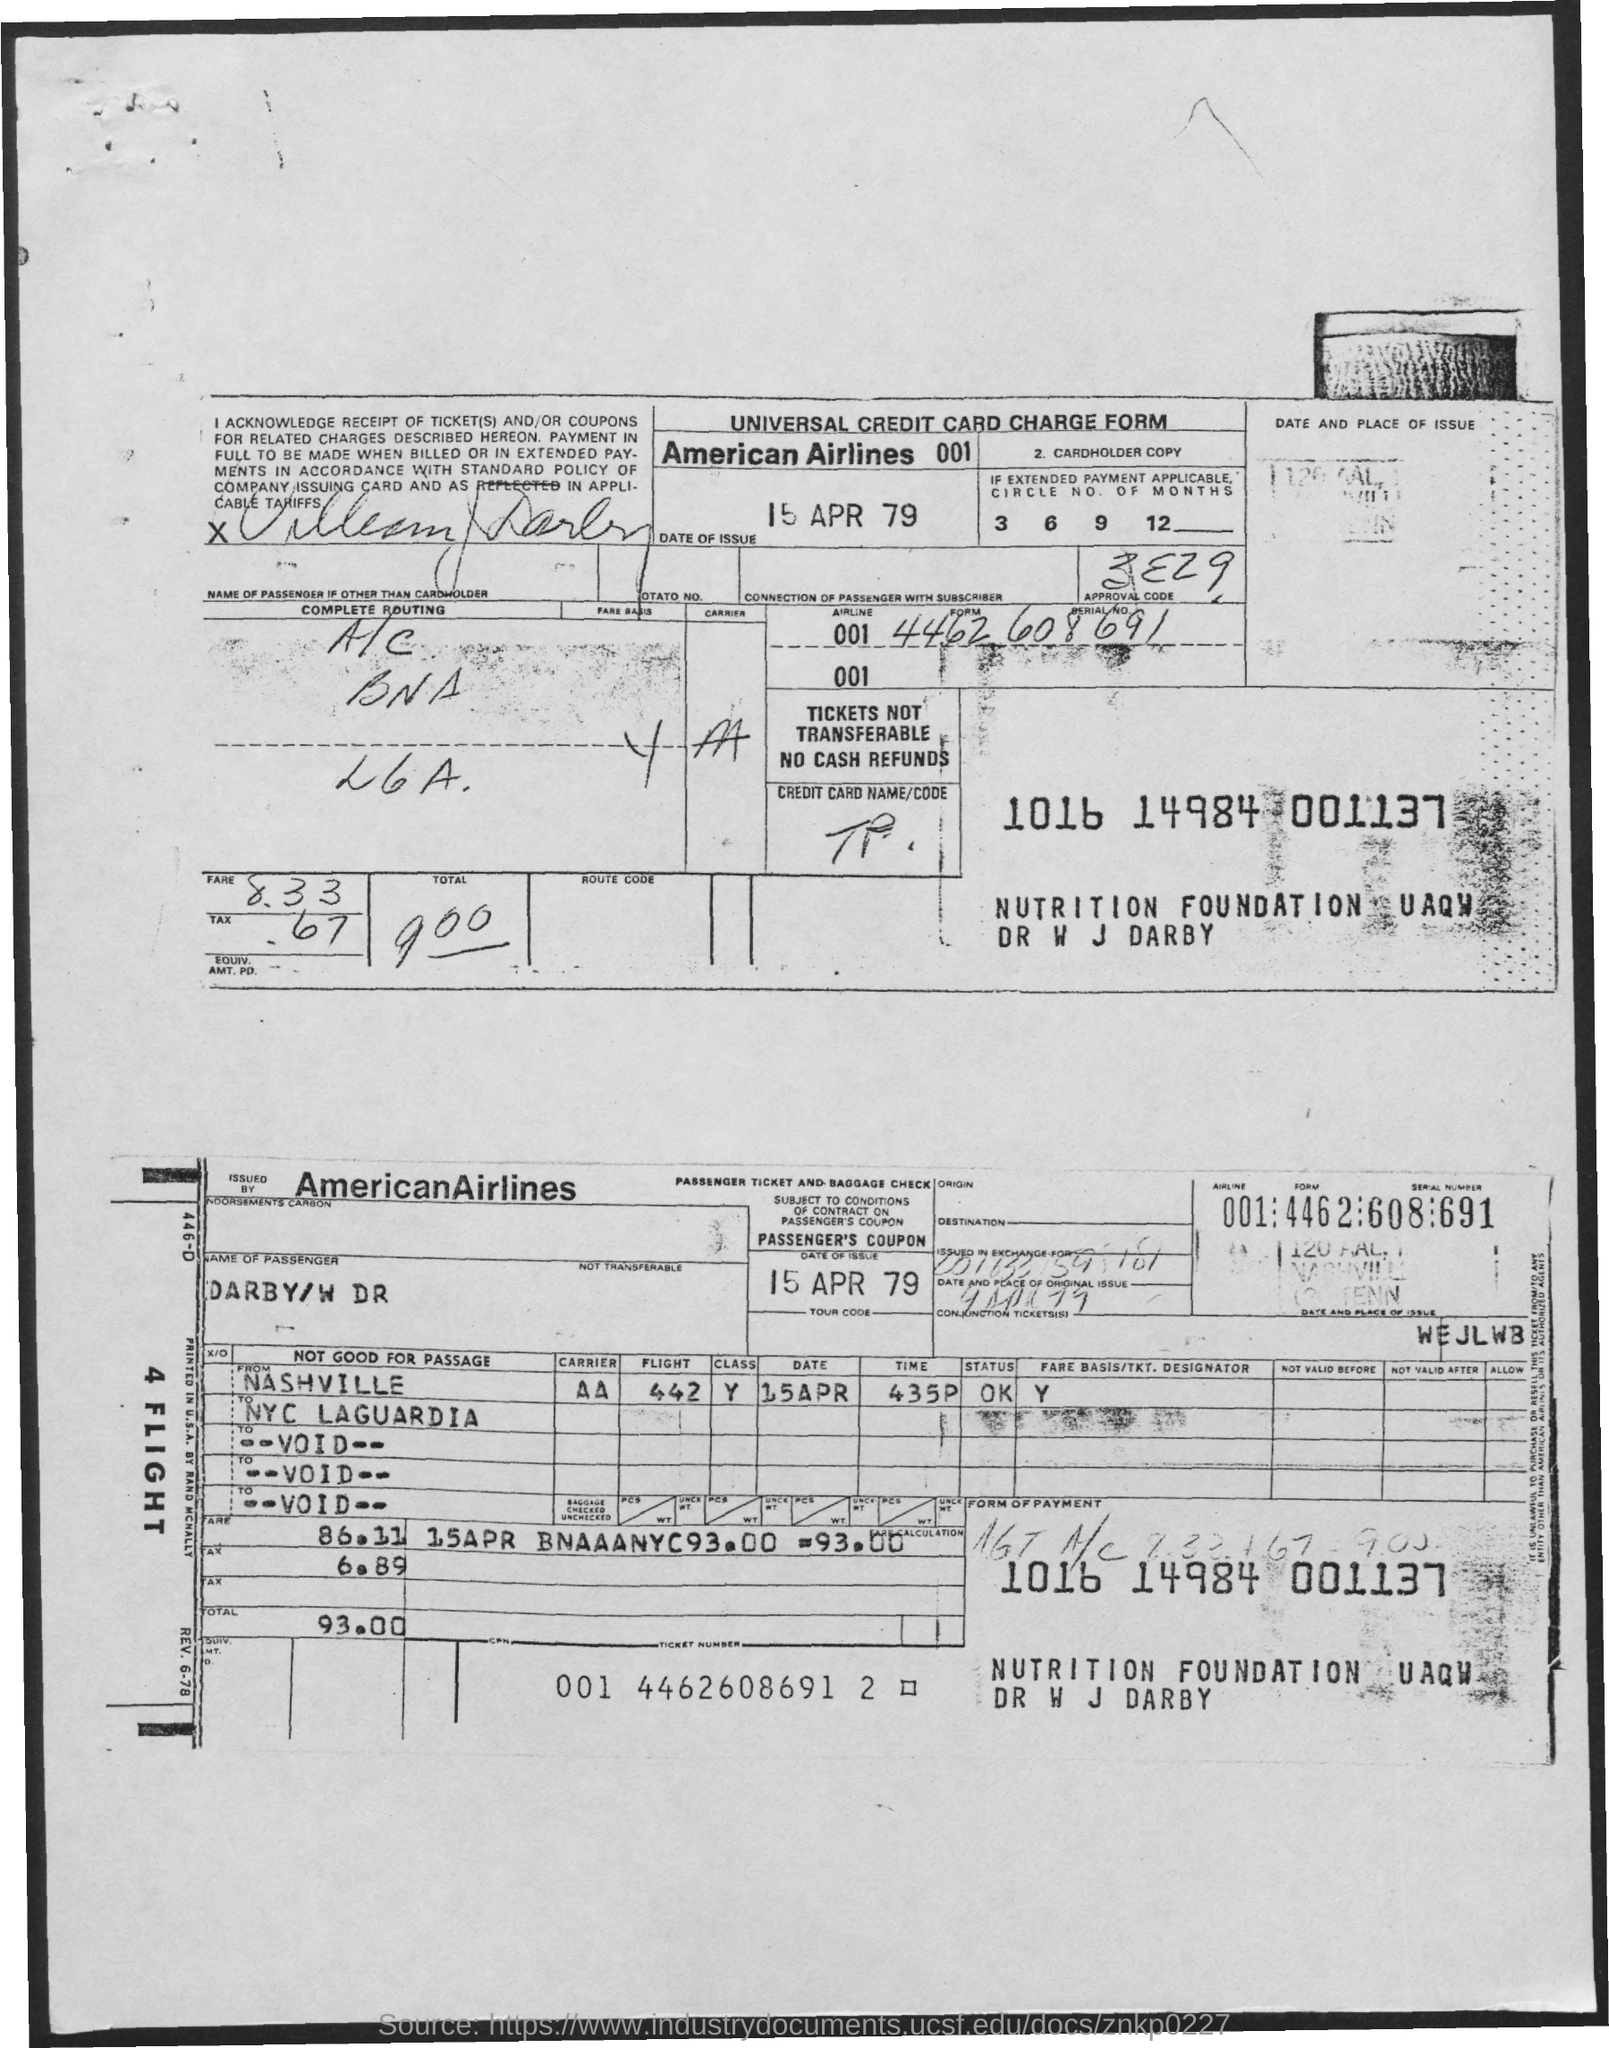Point out several critical features in this image. This form belongs to American Airlines. The form in question is for Universal Credit, and it appears to be a charge form. The date of issue of the form was April 15, 1979. 